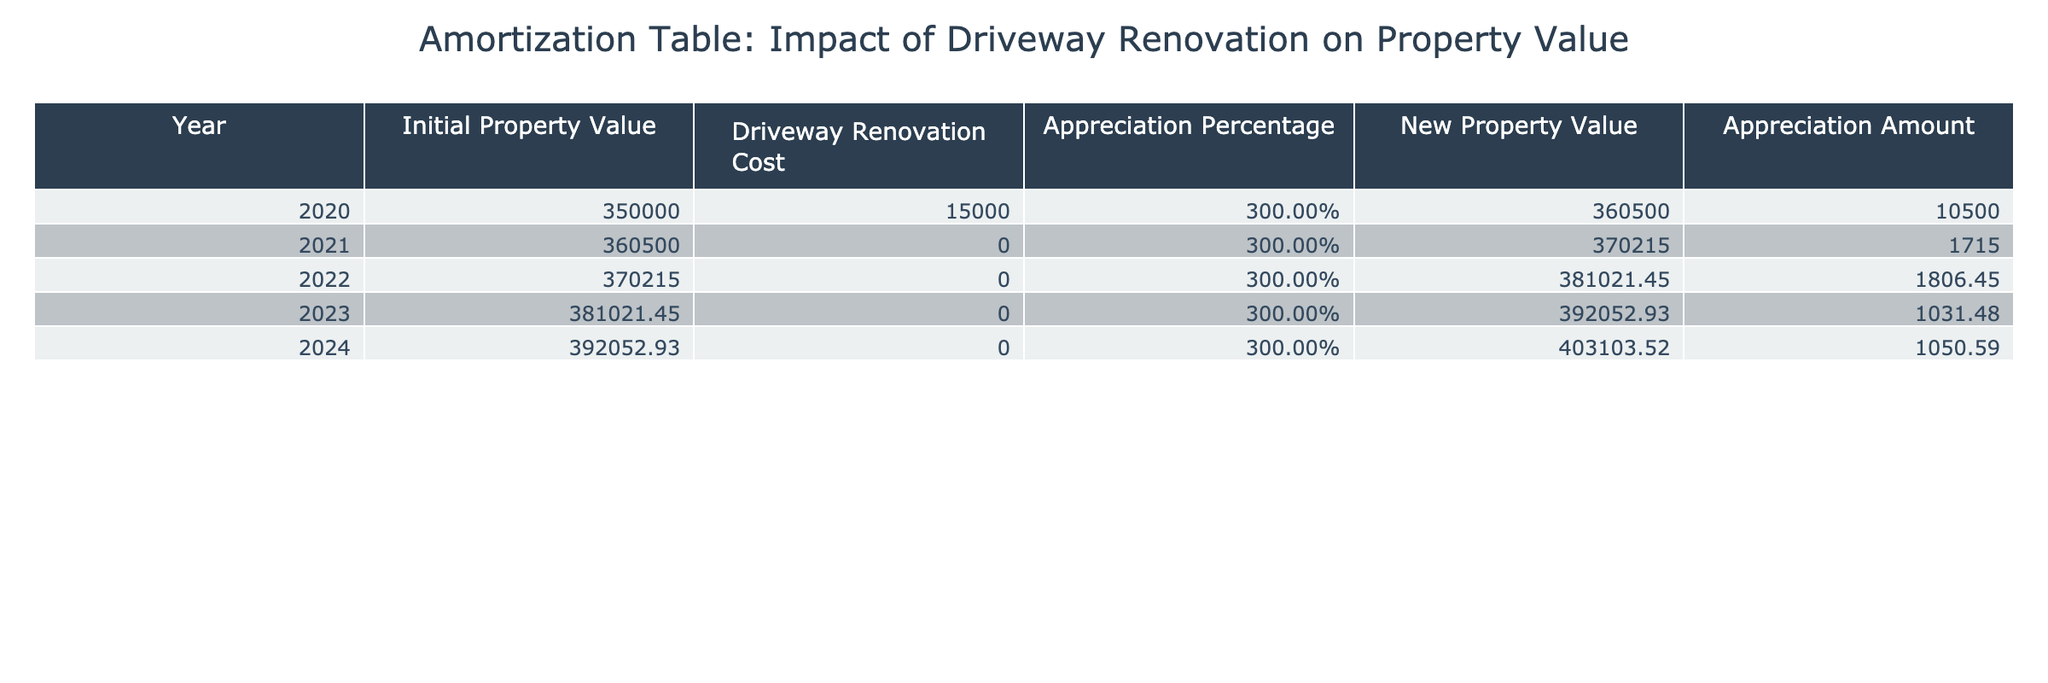What was the total cost of the driveway renovation in the year 2020? The table lists the driveway renovation cost for the year 2020 as $15,000. Therefore, the total cost of the driveway renovation is simply the value stated in that row.
Answer: 15000 What is the new property value at the end of 2024? According to the table, the new property value at the end of 2024 is given as $403,103.52. This value is taken directly from the corresponding row in the table.
Answer: 403103.52 What is the appreciation amount from 2020 to 2021? To find the appreciation amount from 2020 to 2021, we take the new property value for 2021 ($370,215) and subtract the initial property value for 2020 ($360,500): 370215 - 360500 = 1715.
Answer: 1715 Was the appreciation percentage constant over the years? The appreciation percentage remains at 3% for each year in the provided data, indicating that it was constant throughout this period.
Answer: Yes What is the total appreciation amount from 2020 to 2024? To calculate the total appreciation amount from 2020 to 2024, we sum the appreciation amounts for each year: 10,500 + 1,715 + 1,806.45 + 1,031.48 + 1,050.59 = 16,103.52.
Answer: 16103.52 How much did the property value increase in 2023 compared to 2022? The property value in 2022 was $381,021.45, whereas in 2023 it rose to $392,052.93. To find the increase, we subtract: 392052.93 - 381021.45 = 1,031.48.
Answer: 1031.48 Is the property value in 2022 higher than the initial property value in 2020? The initial property value in 2020 was $350,000, while the property value for 2022 is $381,021.45, indicating that 2022's value is indeed higher than the initial value.
Answer: Yes What is the average annual appreciation amount from 2020 to 2024? First, we find the total appreciation amount of $16,103.52 over the five years (2020 to 2024), then divide this by 5 years: 16103.52 / 5 = 3,220.704.
Answer: 3220.704 What was the property value increase from 2021 to 2022? The property value in 2021 is $370,215, and in 2022 it is $381,021.45. We find the increase by subtracting: 381021.45 - 370215 = 1,806.45.
Answer: 1806.45 